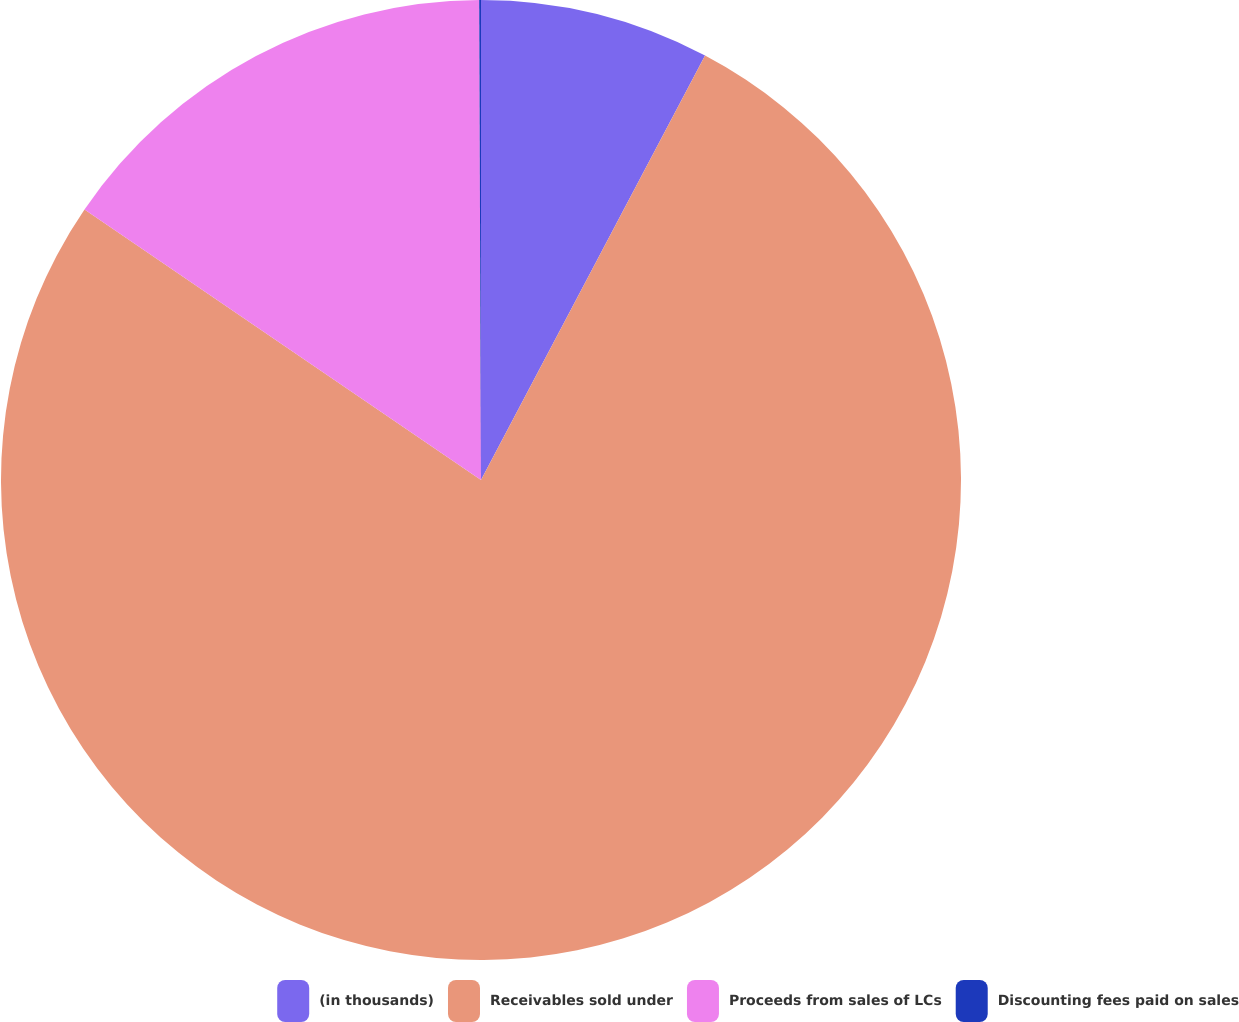<chart> <loc_0><loc_0><loc_500><loc_500><pie_chart><fcel>(in thousands)<fcel>Receivables sold under<fcel>Proceeds from sales of LCs<fcel>Discounting fees paid on sales<nl><fcel>7.73%<fcel>76.8%<fcel>15.41%<fcel>0.06%<nl></chart> 